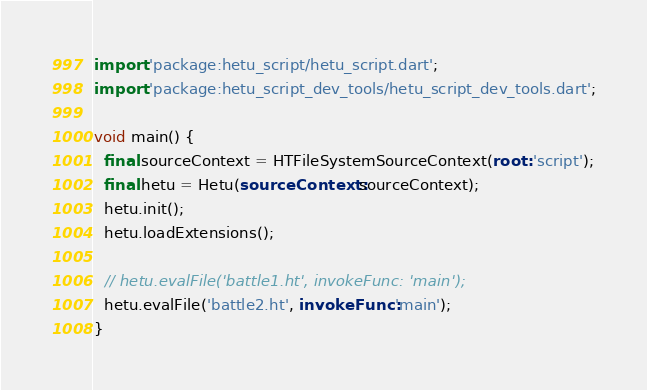Convert code to text. <code><loc_0><loc_0><loc_500><loc_500><_Dart_>import 'package:hetu_script/hetu_script.dart';
import 'package:hetu_script_dev_tools/hetu_script_dev_tools.dart';

void main() {
  final sourceContext = HTFileSystemSourceContext(root: 'script');
  final hetu = Hetu(sourceContext: sourceContext);
  hetu.init();
  hetu.loadExtensions();

  // hetu.evalFile('battle1.ht', invokeFunc: 'main');
  hetu.evalFile('battle2.ht', invokeFunc: 'main');
}
</code> 